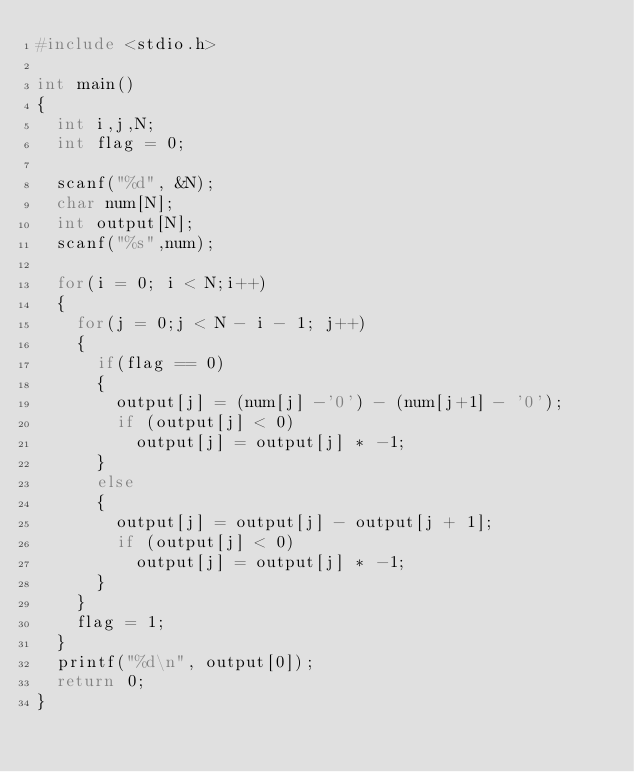Convert code to text. <code><loc_0><loc_0><loc_500><loc_500><_C_>#include <stdio.h>

int main()
{
	int i,j,N;
	int flag = 0;

	scanf("%d", &N);
	char num[N];
	int output[N];
	scanf("%s",num);

	for(i = 0; i < N;i++)
	{
		for(j = 0;j < N - i - 1; j++)
		{
			if(flag == 0)
			{
				output[j] = (num[j] -'0') - (num[j+1] - '0');
				if (output[j] < 0)
					output[j] = output[j] * -1;
			}
			else
			{
				output[j] = output[j] - output[j + 1];
				if (output[j] < 0)
					output[j] = output[j] * -1;
			}
		}
		flag = 1;
	}
	printf("%d\n", output[0]);
	return 0;
}</code> 